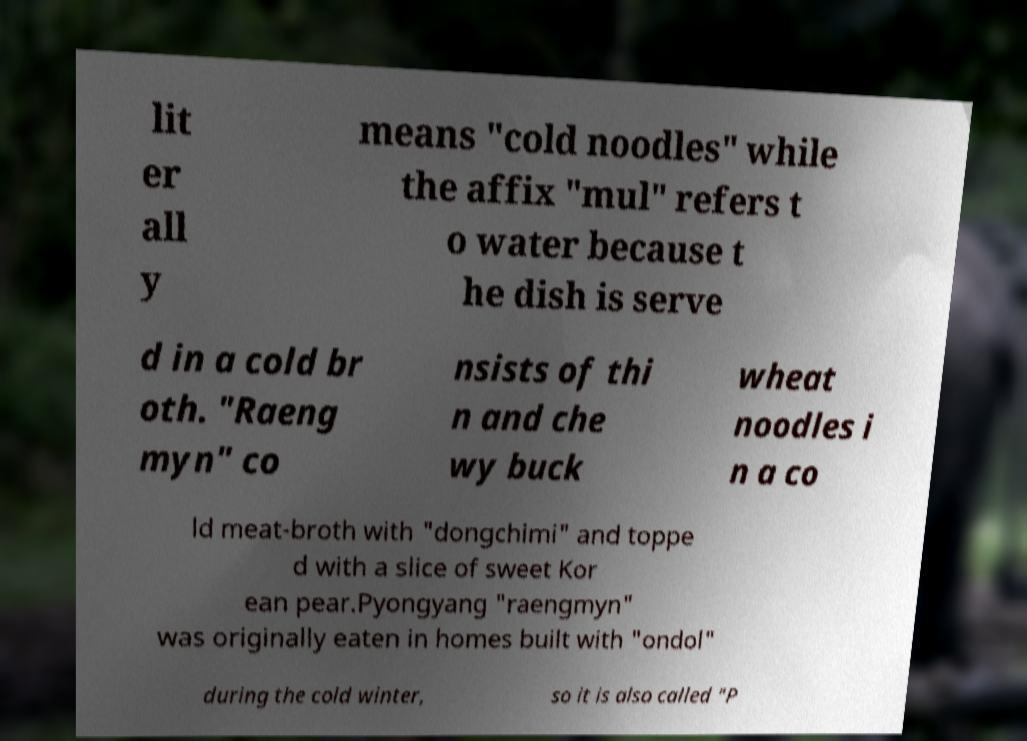Can you accurately transcribe the text from the provided image for me? lit er all y means "cold noodles" while the affix "mul" refers t o water because t he dish is serve d in a cold br oth. "Raeng myn" co nsists of thi n and che wy buck wheat noodles i n a co ld meat-broth with "dongchimi" and toppe d with a slice of sweet Kor ean pear.Pyongyang "raengmyn" was originally eaten in homes built with "ondol" during the cold winter, so it is also called "P 